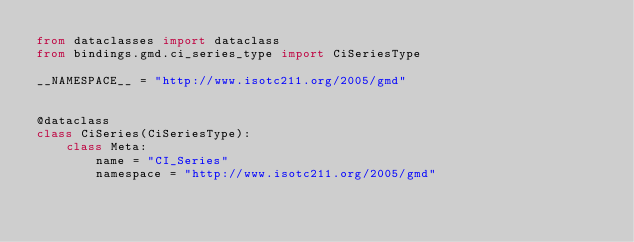Convert code to text. <code><loc_0><loc_0><loc_500><loc_500><_Python_>from dataclasses import dataclass
from bindings.gmd.ci_series_type import CiSeriesType

__NAMESPACE__ = "http://www.isotc211.org/2005/gmd"


@dataclass
class CiSeries(CiSeriesType):
    class Meta:
        name = "CI_Series"
        namespace = "http://www.isotc211.org/2005/gmd"
</code> 